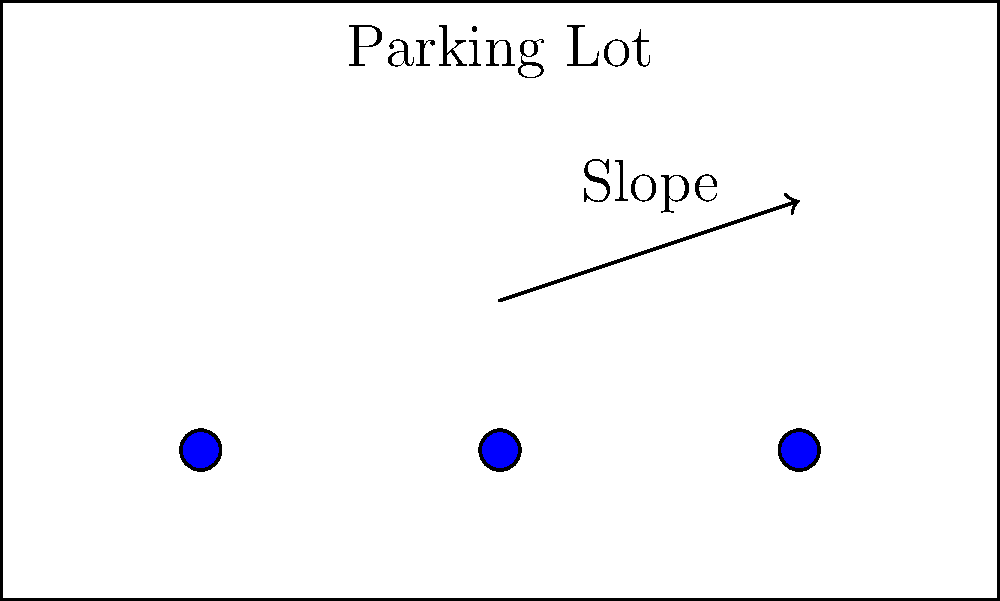You're designing a parking lot for a new shopping center. What's the minimum slope percentage needed for effective water drainage without causing discomfort for pedestrians or vehicles? To determine the optimal slope for water drainage in a parking lot, we need to consider several factors:

1. Minimum slope for drainage: The minimum slope required for effective water drainage is typically 1%. This ensures that water will flow towards drainage points and not pool on the surface.

2. Maximum slope for comfort: The maximum slope for pedestrian comfort is generally considered to be 5%. Anything steeper can be difficult for people to walk on, especially those with mobility issues.

3. Vehicle considerations: For vehicles, a slope of up to 8% is generally acceptable for parking areas. However, steeper slopes can make it difficult for cars to park and may cause them to roll if not properly secured.

4. Local building codes: Always check local building codes, as they may have specific requirements for parking lot slopes.

5. Climate considerations: In areas with heavy rainfall or snowfall, a slightly steeper slope (2-3%) might be preferred to ensure rapid water removal.

Balancing these factors, the optimal slope for a parking lot typically falls between 1% and 2%. This range provides effective drainage while maintaining comfort for both pedestrians and vehicles.

Therefore, the minimum slope percentage needed for effective water drainage, without causing discomfort, is 1%.
Answer: 1% 